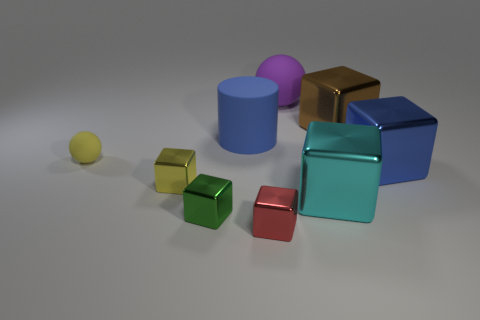Could you use these objects to explain basic geometry to a child? Absolutely, these objects could serve as excellent visual aids for teaching basic geometric concepts to a child, such as identifying different shapes (cylinders, cubes), comparing sizes, and understanding colors. Which shapes correspond to which objects? The cylinders are the large blue and small pink objects, the cubes are represented by the gold, teal, red, green, and smaller yellow and pink objects, and there is a single sphere, which is the very small yellow object. 